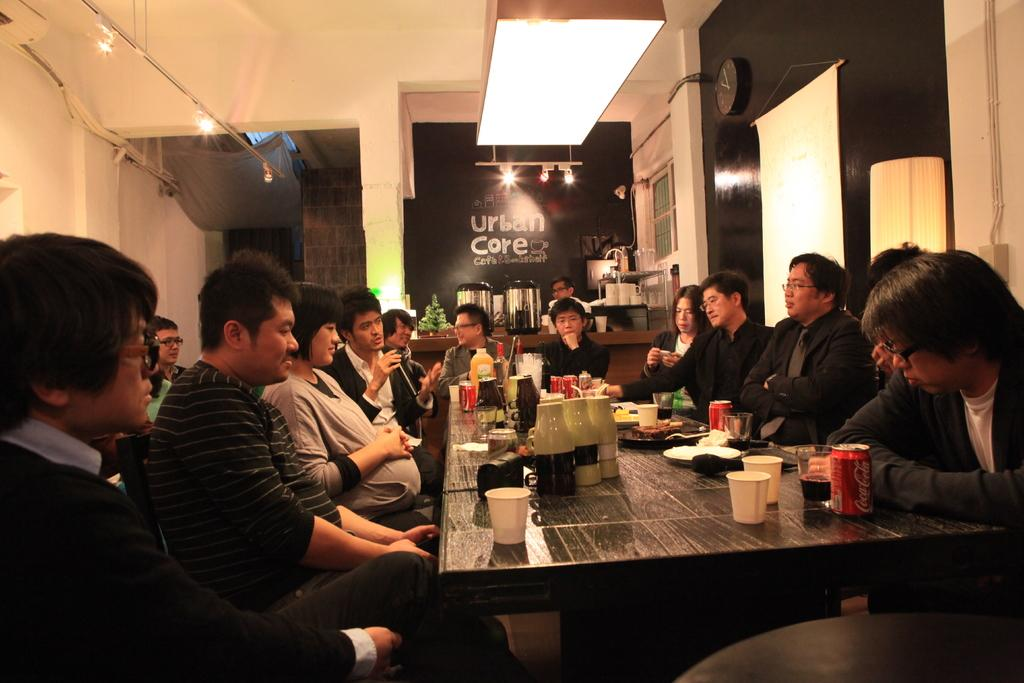<image>
Summarize the visual content of the image. A large group of people sit at a table at Urban Core. 